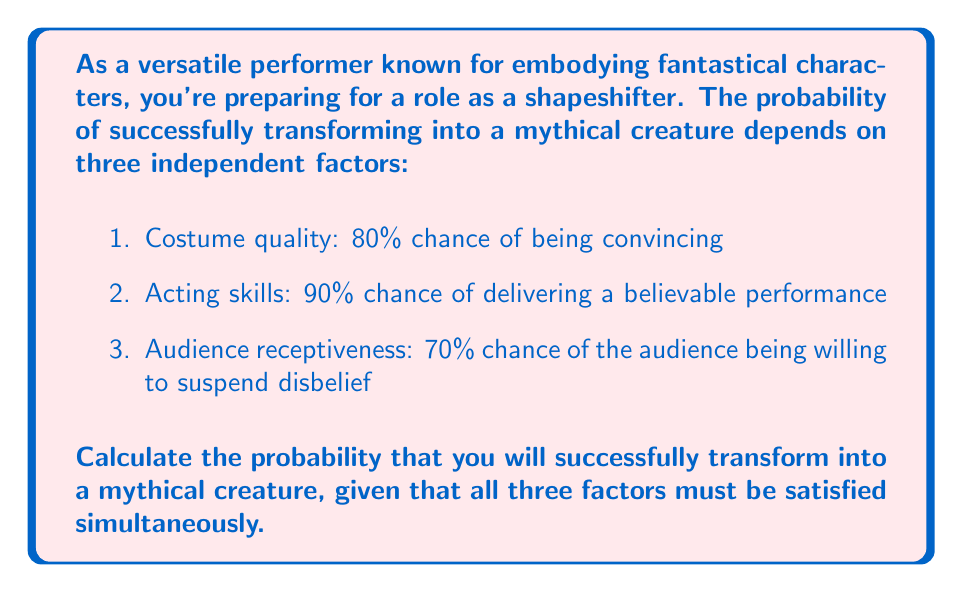Give your solution to this math problem. To solve this problem, we need to use the multiplication rule for independent events. Since all three factors must be satisfied simultaneously, we multiply their individual probabilities:

1. Let's define our events:
   A: Costume is convincing
   B: Acting performance is believable
   C: Audience is receptive

2. Given probabilities:
   P(A) = 0.80
   P(B) = 0.90
   P(C) = 0.70

3. The probability of all three events occurring simultaneously is:
   
   $$P(A \cap B \cap C) = P(A) \cdot P(B) \cdot P(C)$$

4. Substituting the values:
   
   $$P(A \cap B \cap C) = 0.80 \cdot 0.90 \cdot 0.70$$

5. Calculate:
   
   $$P(A \cap B \cap C) = 0.504$$

6. Convert to percentage:
   
   $$0.504 \cdot 100\% = 50.4\%$$

Therefore, the probability of successfully transforming into a mythical creature, given all three factors must be satisfied, is 50.4%.
Answer: 50.4% 